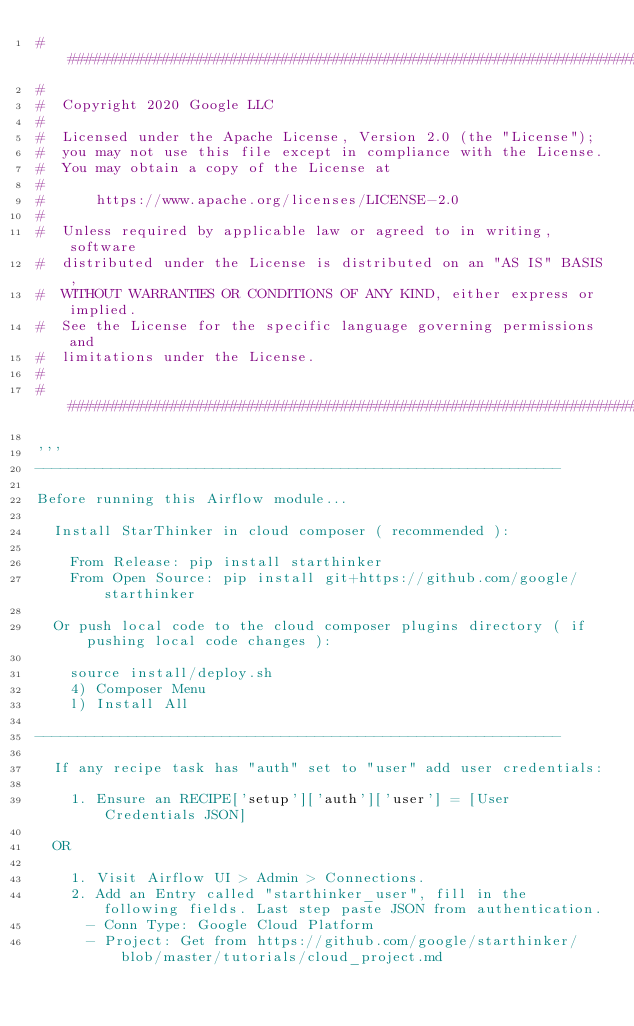<code> <loc_0><loc_0><loc_500><loc_500><_Python_>###########################################################################
#
#  Copyright 2020 Google LLC
#
#  Licensed under the Apache License, Version 2.0 (the "License");
#  you may not use this file except in compliance with the License.
#  You may obtain a copy of the License at
#
#      https://www.apache.org/licenses/LICENSE-2.0
#
#  Unless required by applicable law or agreed to in writing, software
#  distributed under the License is distributed on an "AS IS" BASIS,
#  WITHOUT WARRANTIES OR CONDITIONS OF ANY KIND, either express or implied.
#  See the License for the specific language governing permissions and
#  limitations under the License.
#
###########################################################################

'''
--------------------------------------------------------------

Before running this Airflow module...

  Install StarThinker in cloud composer ( recommended ):

    From Release: pip install starthinker
    From Open Source: pip install git+https://github.com/google/starthinker

  Or push local code to the cloud composer plugins directory ( if pushing local code changes ):

    source install/deploy.sh
    4) Composer Menu
    l) Install All

--------------------------------------------------------------

  If any recipe task has "auth" set to "user" add user credentials:

    1. Ensure an RECIPE['setup']['auth']['user'] = [User Credentials JSON]

  OR

    1. Visit Airflow UI > Admin > Connections.
    2. Add an Entry called "starthinker_user", fill in the following fields. Last step paste JSON from authentication.
      - Conn Type: Google Cloud Platform
      - Project: Get from https://github.com/google/starthinker/blob/master/tutorials/cloud_project.md</code> 